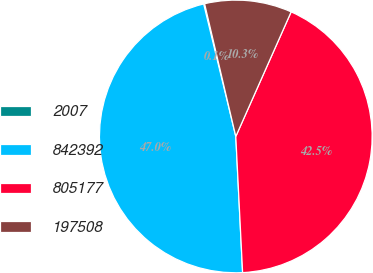Convert chart. <chart><loc_0><loc_0><loc_500><loc_500><pie_chart><fcel>2007<fcel>842392<fcel>805177<fcel>197508<nl><fcel>0.11%<fcel>47.01%<fcel>42.55%<fcel>10.33%<nl></chart> 